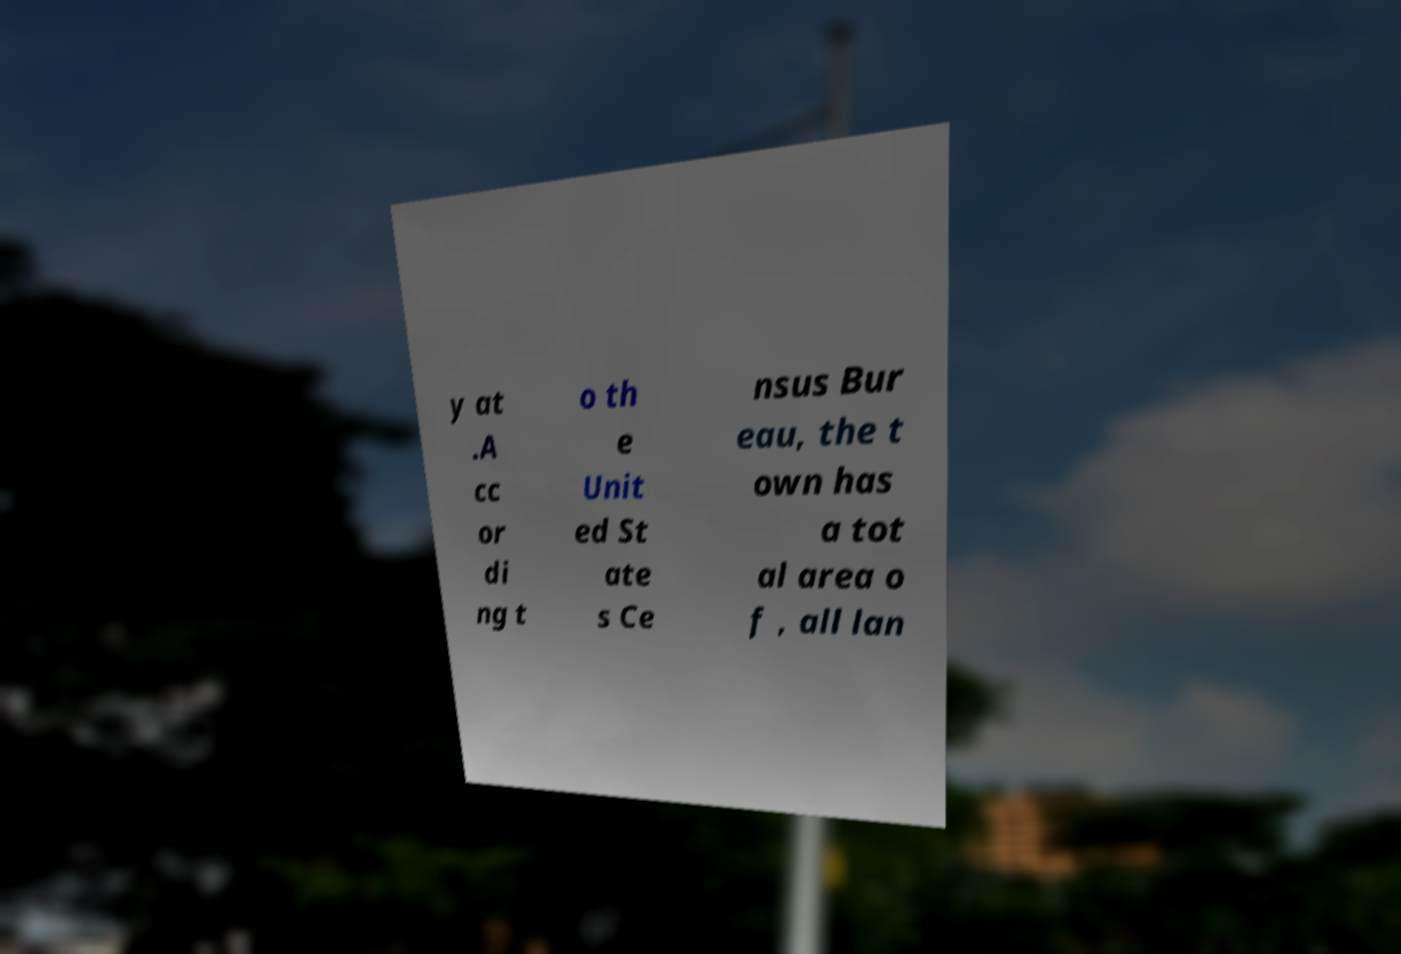I need the written content from this picture converted into text. Can you do that? y at .A cc or di ng t o th e Unit ed St ate s Ce nsus Bur eau, the t own has a tot al area o f , all lan 